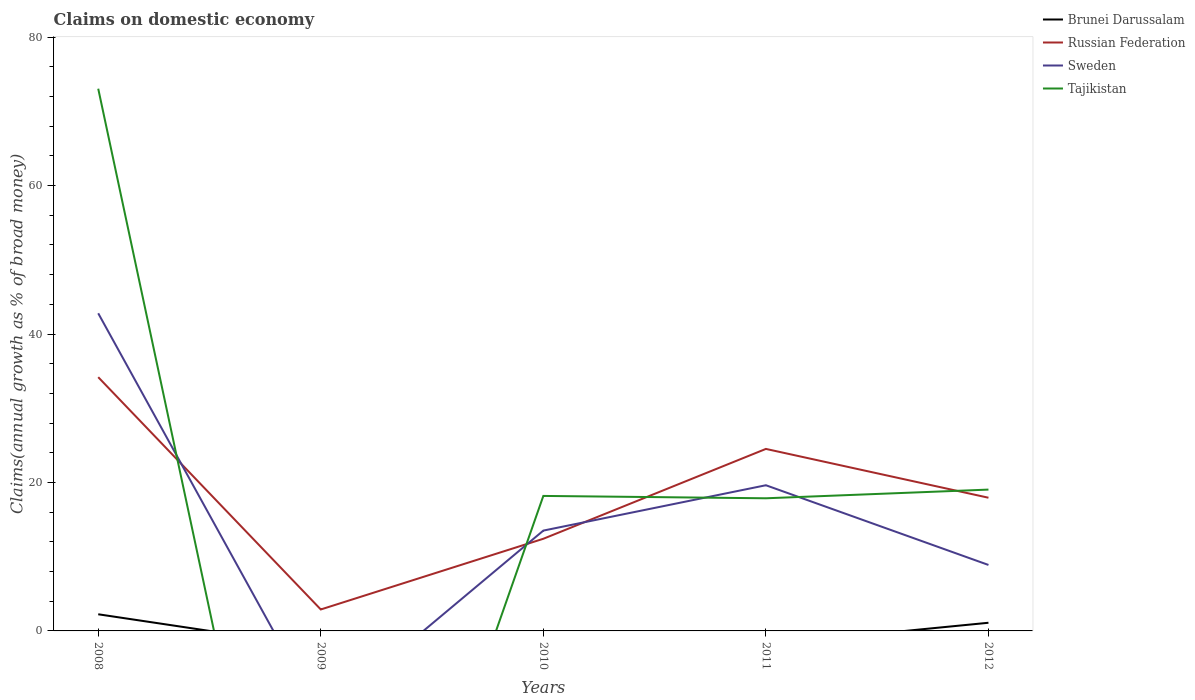Is the number of lines equal to the number of legend labels?
Provide a short and direct response. No. Across all years, what is the maximum percentage of broad money claimed on domestic economy in Russian Federation?
Keep it short and to the point. 2.89. What is the total percentage of broad money claimed on domestic economy in Tajikistan in the graph?
Provide a succinct answer. 54.01. What is the difference between the highest and the second highest percentage of broad money claimed on domestic economy in Russian Federation?
Provide a short and direct response. 31.3. Is the percentage of broad money claimed on domestic economy in Russian Federation strictly greater than the percentage of broad money claimed on domestic economy in Brunei Darussalam over the years?
Offer a very short reply. No. What is the difference between two consecutive major ticks on the Y-axis?
Provide a succinct answer. 20. Are the values on the major ticks of Y-axis written in scientific E-notation?
Offer a very short reply. No. Does the graph contain grids?
Your response must be concise. No. Where does the legend appear in the graph?
Your answer should be very brief. Top right. How many legend labels are there?
Provide a succinct answer. 4. What is the title of the graph?
Provide a succinct answer. Claims on domestic economy. Does "Curacao" appear as one of the legend labels in the graph?
Give a very brief answer. No. What is the label or title of the Y-axis?
Ensure brevity in your answer.  Claims(annual growth as % of broad money). What is the Claims(annual growth as % of broad money) of Brunei Darussalam in 2008?
Offer a very short reply. 2.24. What is the Claims(annual growth as % of broad money) of Russian Federation in 2008?
Your answer should be very brief. 34.19. What is the Claims(annual growth as % of broad money) of Sweden in 2008?
Keep it short and to the point. 42.8. What is the Claims(annual growth as % of broad money) of Tajikistan in 2008?
Your answer should be compact. 73.05. What is the Claims(annual growth as % of broad money) in Brunei Darussalam in 2009?
Provide a short and direct response. 0. What is the Claims(annual growth as % of broad money) in Russian Federation in 2009?
Give a very brief answer. 2.89. What is the Claims(annual growth as % of broad money) of Sweden in 2009?
Your answer should be compact. 0. What is the Claims(annual growth as % of broad money) of Tajikistan in 2009?
Your answer should be very brief. 0. What is the Claims(annual growth as % of broad money) in Brunei Darussalam in 2010?
Keep it short and to the point. 0. What is the Claims(annual growth as % of broad money) of Russian Federation in 2010?
Give a very brief answer. 12.42. What is the Claims(annual growth as % of broad money) in Sweden in 2010?
Make the answer very short. 13.52. What is the Claims(annual growth as % of broad money) of Tajikistan in 2010?
Make the answer very short. 18.19. What is the Claims(annual growth as % of broad money) of Brunei Darussalam in 2011?
Offer a terse response. 0. What is the Claims(annual growth as % of broad money) in Russian Federation in 2011?
Your answer should be very brief. 24.52. What is the Claims(annual growth as % of broad money) in Sweden in 2011?
Offer a terse response. 19.63. What is the Claims(annual growth as % of broad money) in Tajikistan in 2011?
Your answer should be compact. 17.87. What is the Claims(annual growth as % of broad money) of Brunei Darussalam in 2012?
Offer a very short reply. 1.1. What is the Claims(annual growth as % of broad money) of Russian Federation in 2012?
Offer a very short reply. 17.95. What is the Claims(annual growth as % of broad money) of Sweden in 2012?
Provide a short and direct response. 8.89. What is the Claims(annual growth as % of broad money) in Tajikistan in 2012?
Give a very brief answer. 19.04. Across all years, what is the maximum Claims(annual growth as % of broad money) in Brunei Darussalam?
Give a very brief answer. 2.24. Across all years, what is the maximum Claims(annual growth as % of broad money) in Russian Federation?
Your response must be concise. 34.19. Across all years, what is the maximum Claims(annual growth as % of broad money) of Sweden?
Keep it short and to the point. 42.8. Across all years, what is the maximum Claims(annual growth as % of broad money) of Tajikistan?
Your answer should be compact. 73.05. Across all years, what is the minimum Claims(annual growth as % of broad money) of Brunei Darussalam?
Your response must be concise. 0. Across all years, what is the minimum Claims(annual growth as % of broad money) of Russian Federation?
Your response must be concise. 2.89. Across all years, what is the minimum Claims(annual growth as % of broad money) of Sweden?
Provide a short and direct response. 0. What is the total Claims(annual growth as % of broad money) in Brunei Darussalam in the graph?
Your answer should be very brief. 3.34. What is the total Claims(annual growth as % of broad money) in Russian Federation in the graph?
Keep it short and to the point. 91.96. What is the total Claims(annual growth as % of broad money) in Sweden in the graph?
Keep it short and to the point. 84.83. What is the total Claims(annual growth as % of broad money) in Tajikistan in the graph?
Provide a short and direct response. 128.15. What is the difference between the Claims(annual growth as % of broad money) in Russian Federation in 2008 and that in 2009?
Provide a short and direct response. 31.3. What is the difference between the Claims(annual growth as % of broad money) in Russian Federation in 2008 and that in 2010?
Your answer should be very brief. 21.77. What is the difference between the Claims(annual growth as % of broad money) in Sweden in 2008 and that in 2010?
Provide a succinct answer. 29.28. What is the difference between the Claims(annual growth as % of broad money) in Tajikistan in 2008 and that in 2010?
Keep it short and to the point. 54.87. What is the difference between the Claims(annual growth as % of broad money) of Russian Federation in 2008 and that in 2011?
Provide a short and direct response. 9.67. What is the difference between the Claims(annual growth as % of broad money) in Sweden in 2008 and that in 2011?
Make the answer very short. 23.17. What is the difference between the Claims(annual growth as % of broad money) of Tajikistan in 2008 and that in 2011?
Ensure brevity in your answer.  55.18. What is the difference between the Claims(annual growth as % of broad money) in Brunei Darussalam in 2008 and that in 2012?
Give a very brief answer. 1.14. What is the difference between the Claims(annual growth as % of broad money) of Russian Federation in 2008 and that in 2012?
Provide a succinct answer. 16.24. What is the difference between the Claims(annual growth as % of broad money) of Sweden in 2008 and that in 2012?
Ensure brevity in your answer.  33.91. What is the difference between the Claims(annual growth as % of broad money) in Tajikistan in 2008 and that in 2012?
Your response must be concise. 54.01. What is the difference between the Claims(annual growth as % of broad money) in Russian Federation in 2009 and that in 2010?
Offer a terse response. -9.53. What is the difference between the Claims(annual growth as % of broad money) in Russian Federation in 2009 and that in 2011?
Keep it short and to the point. -21.63. What is the difference between the Claims(annual growth as % of broad money) of Russian Federation in 2009 and that in 2012?
Offer a very short reply. -15.05. What is the difference between the Claims(annual growth as % of broad money) of Russian Federation in 2010 and that in 2011?
Your response must be concise. -12.1. What is the difference between the Claims(annual growth as % of broad money) in Sweden in 2010 and that in 2011?
Provide a succinct answer. -6.11. What is the difference between the Claims(annual growth as % of broad money) of Tajikistan in 2010 and that in 2011?
Offer a terse response. 0.32. What is the difference between the Claims(annual growth as % of broad money) of Russian Federation in 2010 and that in 2012?
Provide a short and direct response. -5.53. What is the difference between the Claims(annual growth as % of broad money) of Sweden in 2010 and that in 2012?
Your answer should be compact. 4.63. What is the difference between the Claims(annual growth as % of broad money) in Tajikistan in 2010 and that in 2012?
Provide a succinct answer. -0.85. What is the difference between the Claims(annual growth as % of broad money) in Russian Federation in 2011 and that in 2012?
Your response must be concise. 6.58. What is the difference between the Claims(annual growth as % of broad money) of Sweden in 2011 and that in 2012?
Your answer should be compact. 10.74. What is the difference between the Claims(annual growth as % of broad money) of Tajikistan in 2011 and that in 2012?
Ensure brevity in your answer.  -1.17. What is the difference between the Claims(annual growth as % of broad money) of Brunei Darussalam in 2008 and the Claims(annual growth as % of broad money) of Russian Federation in 2009?
Provide a succinct answer. -0.65. What is the difference between the Claims(annual growth as % of broad money) of Brunei Darussalam in 2008 and the Claims(annual growth as % of broad money) of Russian Federation in 2010?
Your response must be concise. -10.17. What is the difference between the Claims(annual growth as % of broad money) of Brunei Darussalam in 2008 and the Claims(annual growth as % of broad money) of Sweden in 2010?
Your answer should be very brief. -11.27. What is the difference between the Claims(annual growth as % of broad money) in Brunei Darussalam in 2008 and the Claims(annual growth as % of broad money) in Tajikistan in 2010?
Keep it short and to the point. -15.94. What is the difference between the Claims(annual growth as % of broad money) of Russian Federation in 2008 and the Claims(annual growth as % of broad money) of Sweden in 2010?
Provide a succinct answer. 20.67. What is the difference between the Claims(annual growth as % of broad money) of Russian Federation in 2008 and the Claims(annual growth as % of broad money) of Tajikistan in 2010?
Provide a short and direct response. 16. What is the difference between the Claims(annual growth as % of broad money) in Sweden in 2008 and the Claims(annual growth as % of broad money) in Tajikistan in 2010?
Give a very brief answer. 24.61. What is the difference between the Claims(annual growth as % of broad money) in Brunei Darussalam in 2008 and the Claims(annual growth as % of broad money) in Russian Federation in 2011?
Keep it short and to the point. -22.28. What is the difference between the Claims(annual growth as % of broad money) in Brunei Darussalam in 2008 and the Claims(annual growth as % of broad money) in Sweden in 2011?
Offer a very short reply. -17.38. What is the difference between the Claims(annual growth as % of broad money) in Brunei Darussalam in 2008 and the Claims(annual growth as % of broad money) in Tajikistan in 2011?
Offer a terse response. -15.63. What is the difference between the Claims(annual growth as % of broad money) in Russian Federation in 2008 and the Claims(annual growth as % of broad money) in Sweden in 2011?
Make the answer very short. 14.56. What is the difference between the Claims(annual growth as % of broad money) in Russian Federation in 2008 and the Claims(annual growth as % of broad money) in Tajikistan in 2011?
Your answer should be very brief. 16.32. What is the difference between the Claims(annual growth as % of broad money) in Sweden in 2008 and the Claims(annual growth as % of broad money) in Tajikistan in 2011?
Your response must be concise. 24.92. What is the difference between the Claims(annual growth as % of broad money) in Brunei Darussalam in 2008 and the Claims(annual growth as % of broad money) in Russian Federation in 2012?
Your answer should be very brief. -15.7. What is the difference between the Claims(annual growth as % of broad money) in Brunei Darussalam in 2008 and the Claims(annual growth as % of broad money) in Sweden in 2012?
Offer a very short reply. -6.65. What is the difference between the Claims(annual growth as % of broad money) of Brunei Darussalam in 2008 and the Claims(annual growth as % of broad money) of Tajikistan in 2012?
Provide a succinct answer. -16.8. What is the difference between the Claims(annual growth as % of broad money) in Russian Federation in 2008 and the Claims(annual growth as % of broad money) in Sweden in 2012?
Offer a very short reply. 25.3. What is the difference between the Claims(annual growth as % of broad money) in Russian Federation in 2008 and the Claims(annual growth as % of broad money) in Tajikistan in 2012?
Provide a succinct answer. 15.15. What is the difference between the Claims(annual growth as % of broad money) of Sweden in 2008 and the Claims(annual growth as % of broad money) of Tajikistan in 2012?
Your response must be concise. 23.75. What is the difference between the Claims(annual growth as % of broad money) in Russian Federation in 2009 and the Claims(annual growth as % of broad money) in Sweden in 2010?
Your answer should be compact. -10.63. What is the difference between the Claims(annual growth as % of broad money) in Russian Federation in 2009 and the Claims(annual growth as % of broad money) in Tajikistan in 2010?
Make the answer very short. -15.3. What is the difference between the Claims(annual growth as % of broad money) of Russian Federation in 2009 and the Claims(annual growth as % of broad money) of Sweden in 2011?
Make the answer very short. -16.74. What is the difference between the Claims(annual growth as % of broad money) in Russian Federation in 2009 and the Claims(annual growth as % of broad money) in Tajikistan in 2011?
Give a very brief answer. -14.98. What is the difference between the Claims(annual growth as % of broad money) of Russian Federation in 2009 and the Claims(annual growth as % of broad money) of Sweden in 2012?
Make the answer very short. -6. What is the difference between the Claims(annual growth as % of broad money) in Russian Federation in 2009 and the Claims(annual growth as % of broad money) in Tajikistan in 2012?
Provide a short and direct response. -16.15. What is the difference between the Claims(annual growth as % of broad money) of Russian Federation in 2010 and the Claims(annual growth as % of broad money) of Sweden in 2011?
Your response must be concise. -7.21. What is the difference between the Claims(annual growth as % of broad money) of Russian Federation in 2010 and the Claims(annual growth as % of broad money) of Tajikistan in 2011?
Offer a very short reply. -5.45. What is the difference between the Claims(annual growth as % of broad money) of Sweden in 2010 and the Claims(annual growth as % of broad money) of Tajikistan in 2011?
Make the answer very short. -4.35. What is the difference between the Claims(annual growth as % of broad money) in Russian Federation in 2010 and the Claims(annual growth as % of broad money) in Sweden in 2012?
Give a very brief answer. 3.53. What is the difference between the Claims(annual growth as % of broad money) of Russian Federation in 2010 and the Claims(annual growth as % of broad money) of Tajikistan in 2012?
Make the answer very short. -6.62. What is the difference between the Claims(annual growth as % of broad money) of Sweden in 2010 and the Claims(annual growth as % of broad money) of Tajikistan in 2012?
Ensure brevity in your answer.  -5.52. What is the difference between the Claims(annual growth as % of broad money) in Russian Federation in 2011 and the Claims(annual growth as % of broad money) in Sweden in 2012?
Offer a terse response. 15.63. What is the difference between the Claims(annual growth as % of broad money) of Russian Federation in 2011 and the Claims(annual growth as % of broad money) of Tajikistan in 2012?
Give a very brief answer. 5.48. What is the difference between the Claims(annual growth as % of broad money) in Sweden in 2011 and the Claims(annual growth as % of broad money) in Tajikistan in 2012?
Offer a terse response. 0.59. What is the average Claims(annual growth as % of broad money) of Brunei Darussalam per year?
Your response must be concise. 0.67. What is the average Claims(annual growth as % of broad money) of Russian Federation per year?
Offer a terse response. 18.39. What is the average Claims(annual growth as % of broad money) in Sweden per year?
Your response must be concise. 16.97. What is the average Claims(annual growth as % of broad money) of Tajikistan per year?
Your response must be concise. 25.63. In the year 2008, what is the difference between the Claims(annual growth as % of broad money) of Brunei Darussalam and Claims(annual growth as % of broad money) of Russian Federation?
Provide a short and direct response. -31.94. In the year 2008, what is the difference between the Claims(annual growth as % of broad money) of Brunei Darussalam and Claims(annual growth as % of broad money) of Sweden?
Offer a terse response. -40.55. In the year 2008, what is the difference between the Claims(annual growth as % of broad money) of Brunei Darussalam and Claims(annual growth as % of broad money) of Tajikistan?
Ensure brevity in your answer.  -70.81. In the year 2008, what is the difference between the Claims(annual growth as % of broad money) in Russian Federation and Claims(annual growth as % of broad money) in Sweden?
Give a very brief answer. -8.61. In the year 2008, what is the difference between the Claims(annual growth as % of broad money) of Russian Federation and Claims(annual growth as % of broad money) of Tajikistan?
Your answer should be very brief. -38.87. In the year 2008, what is the difference between the Claims(annual growth as % of broad money) of Sweden and Claims(annual growth as % of broad money) of Tajikistan?
Keep it short and to the point. -30.26. In the year 2010, what is the difference between the Claims(annual growth as % of broad money) in Russian Federation and Claims(annual growth as % of broad money) in Sweden?
Offer a very short reply. -1.1. In the year 2010, what is the difference between the Claims(annual growth as % of broad money) of Russian Federation and Claims(annual growth as % of broad money) of Tajikistan?
Give a very brief answer. -5.77. In the year 2010, what is the difference between the Claims(annual growth as % of broad money) of Sweden and Claims(annual growth as % of broad money) of Tajikistan?
Offer a very short reply. -4.67. In the year 2011, what is the difference between the Claims(annual growth as % of broad money) of Russian Federation and Claims(annual growth as % of broad money) of Sweden?
Give a very brief answer. 4.89. In the year 2011, what is the difference between the Claims(annual growth as % of broad money) in Russian Federation and Claims(annual growth as % of broad money) in Tajikistan?
Ensure brevity in your answer.  6.65. In the year 2011, what is the difference between the Claims(annual growth as % of broad money) of Sweden and Claims(annual growth as % of broad money) of Tajikistan?
Your answer should be very brief. 1.76. In the year 2012, what is the difference between the Claims(annual growth as % of broad money) of Brunei Darussalam and Claims(annual growth as % of broad money) of Russian Federation?
Give a very brief answer. -16.85. In the year 2012, what is the difference between the Claims(annual growth as % of broad money) in Brunei Darussalam and Claims(annual growth as % of broad money) in Sweden?
Make the answer very short. -7.79. In the year 2012, what is the difference between the Claims(annual growth as % of broad money) of Brunei Darussalam and Claims(annual growth as % of broad money) of Tajikistan?
Keep it short and to the point. -17.94. In the year 2012, what is the difference between the Claims(annual growth as % of broad money) in Russian Federation and Claims(annual growth as % of broad money) in Sweden?
Provide a short and direct response. 9.06. In the year 2012, what is the difference between the Claims(annual growth as % of broad money) in Russian Federation and Claims(annual growth as % of broad money) in Tajikistan?
Offer a terse response. -1.1. In the year 2012, what is the difference between the Claims(annual growth as % of broad money) in Sweden and Claims(annual growth as % of broad money) in Tajikistan?
Offer a very short reply. -10.15. What is the ratio of the Claims(annual growth as % of broad money) of Russian Federation in 2008 to that in 2009?
Your answer should be compact. 11.83. What is the ratio of the Claims(annual growth as % of broad money) of Russian Federation in 2008 to that in 2010?
Keep it short and to the point. 2.75. What is the ratio of the Claims(annual growth as % of broad money) in Sweden in 2008 to that in 2010?
Offer a very short reply. 3.17. What is the ratio of the Claims(annual growth as % of broad money) of Tajikistan in 2008 to that in 2010?
Your answer should be compact. 4.02. What is the ratio of the Claims(annual growth as % of broad money) of Russian Federation in 2008 to that in 2011?
Offer a terse response. 1.39. What is the ratio of the Claims(annual growth as % of broad money) of Sweden in 2008 to that in 2011?
Offer a terse response. 2.18. What is the ratio of the Claims(annual growth as % of broad money) of Tajikistan in 2008 to that in 2011?
Provide a short and direct response. 4.09. What is the ratio of the Claims(annual growth as % of broad money) in Brunei Darussalam in 2008 to that in 2012?
Offer a terse response. 2.04. What is the ratio of the Claims(annual growth as % of broad money) in Russian Federation in 2008 to that in 2012?
Offer a very short reply. 1.91. What is the ratio of the Claims(annual growth as % of broad money) in Sweden in 2008 to that in 2012?
Your answer should be very brief. 4.81. What is the ratio of the Claims(annual growth as % of broad money) in Tajikistan in 2008 to that in 2012?
Keep it short and to the point. 3.84. What is the ratio of the Claims(annual growth as % of broad money) of Russian Federation in 2009 to that in 2010?
Ensure brevity in your answer.  0.23. What is the ratio of the Claims(annual growth as % of broad money) in Russian Federation in 2009 to that in 2011?
Give a very brief answer. 0.12. What is the ratio of the Claims(annual growth as % of broad money) of Russian Federation in 2009 to that in 2012?
Your answer should be compact. 0.16. What is the ratio of the Claims(annual growth as % of broad money) of Russian Federation in 2010 to that in 2011?
Your response must be concise. 0.51. What is the ratio of the Claims(annual growth as % of broad money) in Sweden in 2010 to that in 2011?
Make the answer very short. 0.69. What is the ratio of the Claims(annual growth as % of broad money) of Tajikistan in 2010 to that in 2011?
Give a very brief answer. 1.02. What is the ratio of the Claims(annual growth as % of broad money) of Russian Federation in 2010 to that in 2012?
Your response must be concise. 0.69. What is the ratio of the Claims(annual growth as % of broad money) of Sweden in 2010 to that in 2012?
Provide a succinct answer. 1.52. What is the ratio of the Claims(annual growth as % of broad money) in Tajikistan in 2010 to that in 2012?
Provide a short and direct response. 0.96. What is the ratio of the Claims(annual growth as % of broad money) of Russian Federation in 2011 to that in 2012?
Give a very brief answer. 1.37. What is the ratio of the Claims(annual growth as % of broad money) of Sweden in 2011 to that in 2012?
Offer a very short reply. 2.21. What is the ratio of the Claims(annual growth as % of broad money) in Tajikistan in 2011 to that in 2012?
Offer a terse response. 0.94. What is the difference between the highest and the second highest Claims(annual growth as % of broad money) in Russian Federation?
Ensure brevity in your answer.  9.67. What is the difference between the highest and the second highest Claims(annual growth as % of broad money) in Sweden?
Provide a short and direct response. 23.17. What is the difference between the highest and the second highest Claims(annual growth as % of broad money) in Tajikistan?
Your response must be concise. 54.01. What is the difference between the highest and the lowest Claims(annual growth as % of broad money) of Brunei Darussalam?
Your response must be concise. 2.24. What is the difference between the highest and the lowest Claims(annual growth as % of broad money) in Russian Federation?
Give a very brief answer. 31.3. What is the difference between the highest and the lowest Claims(annual growth as % of broad money) in Sweden?
Your answer should be very brief. 42.8. What is the difference between the highest and the lowest Claims(annual growth as % of broad money) of Tajikistan?
Ensure brevity in your answer.  73.05. 